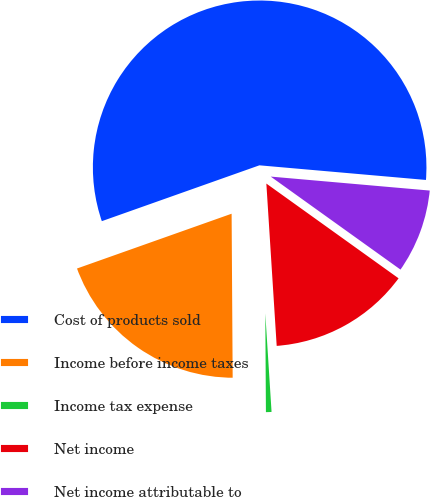Convert chart to OTSL. <chart><loc_0><loc_0><loc_500><loc_500><pie_chart><fcel>Cost of products sold<fcel>Income before income taxes<fcel>Income tax expense<fcel>Net income<fcel>Net income attributable to<nl><fcel>56.81%<fcel>19.68%<fcel>0.91%<fcel>14.09%<fcel>8.5%<nl></chart> 